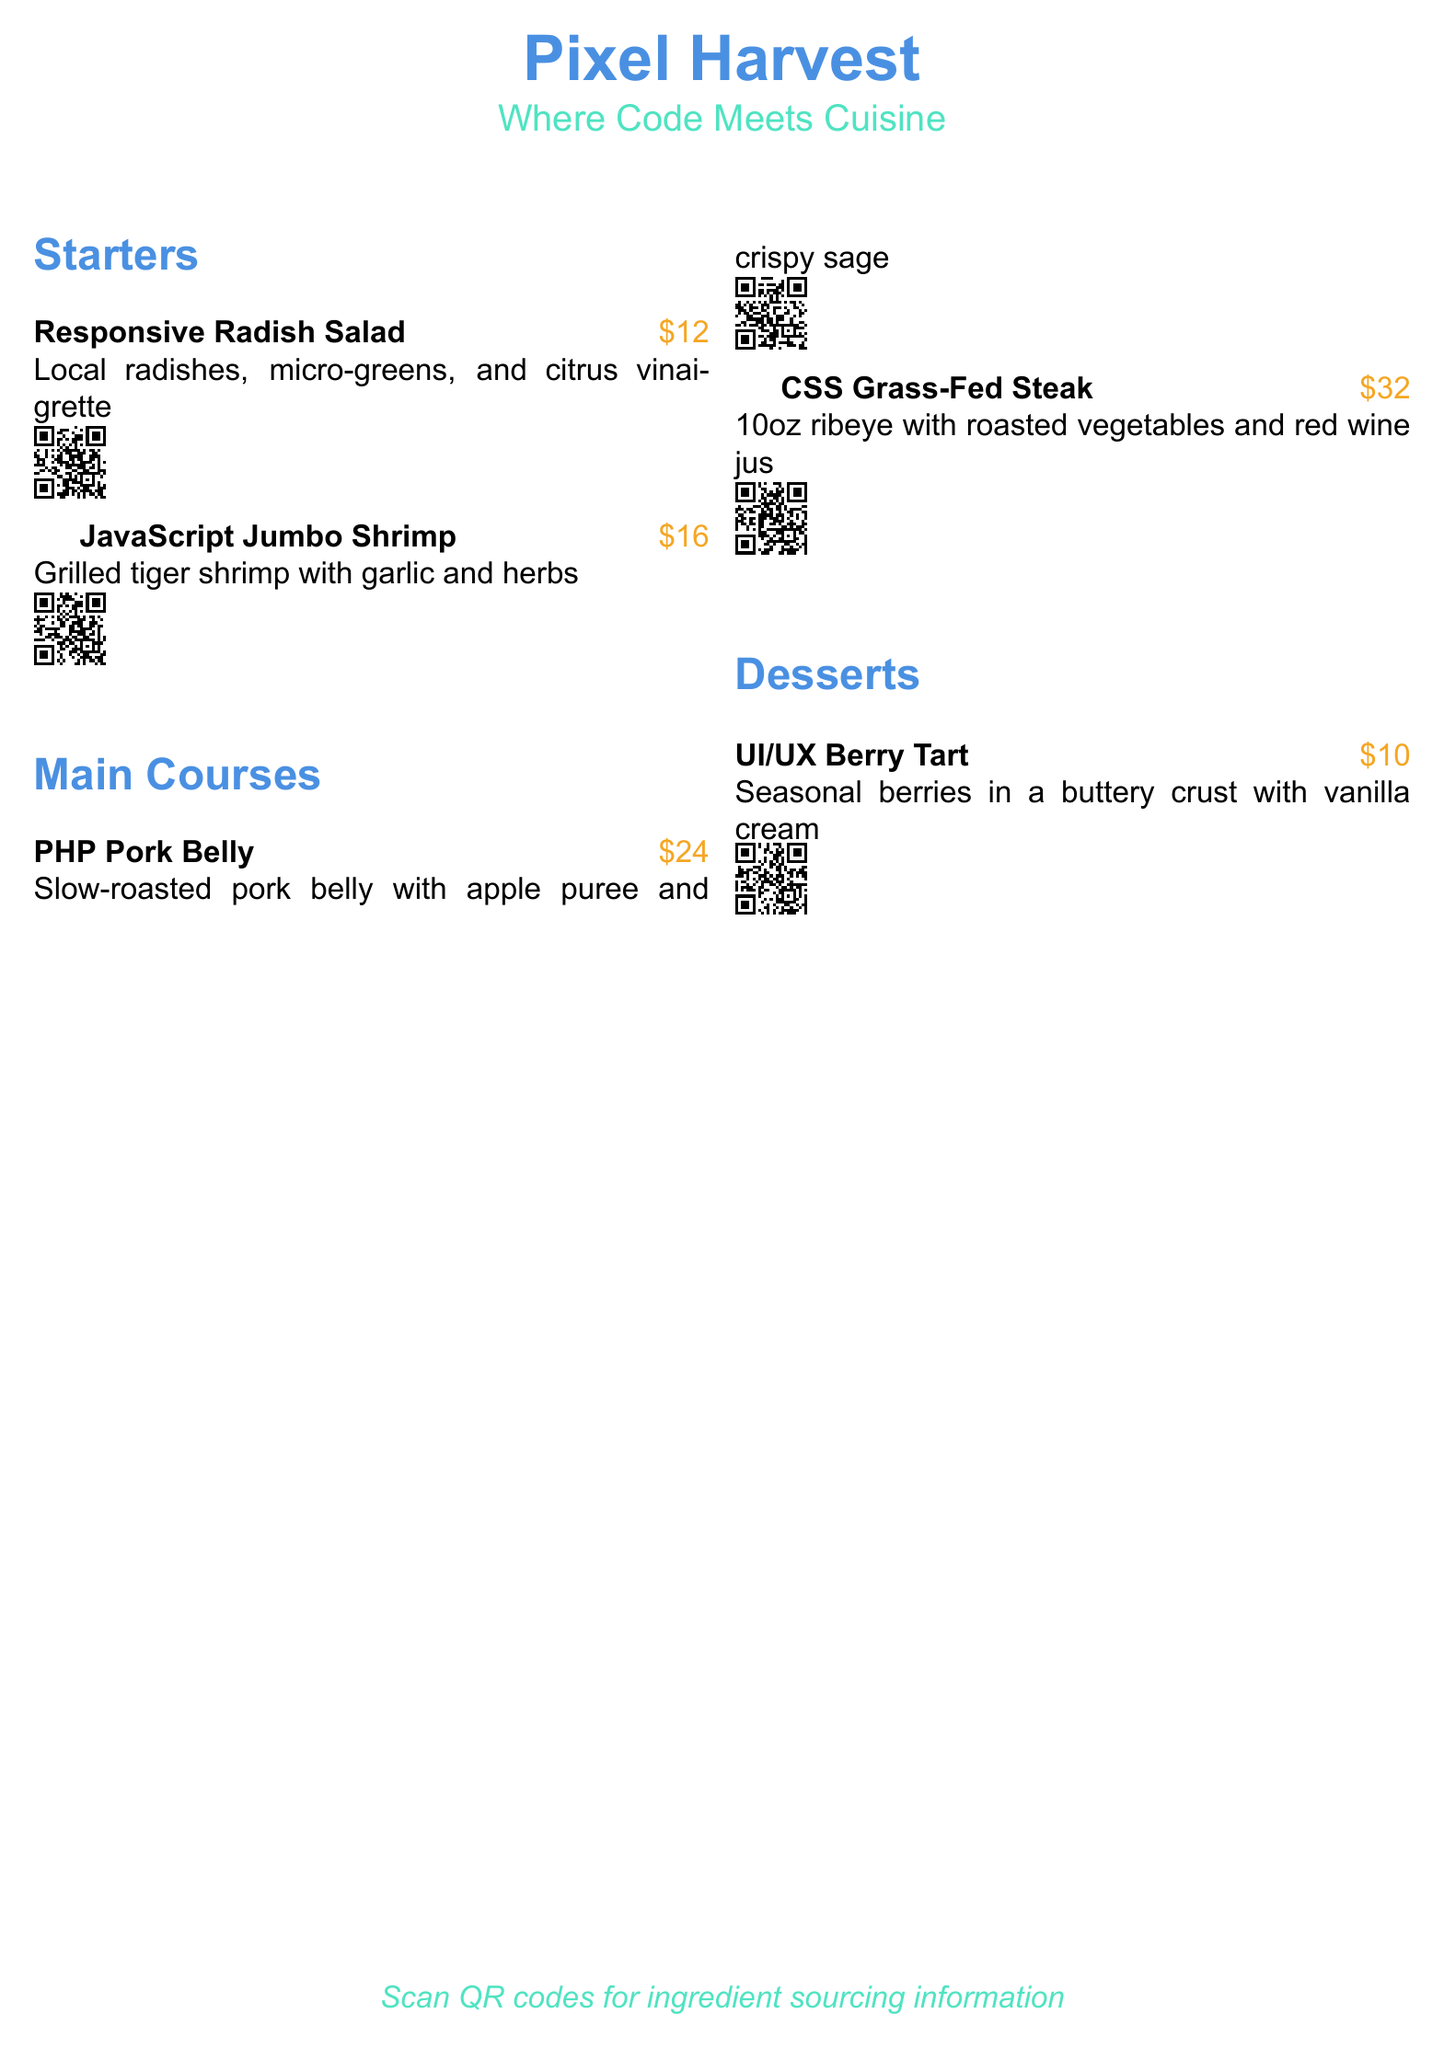What is the name of the restaurant? The name of the restaurant is prominently displayed at the top of the menu.
Answer: Pixel Harvest What is the price of the Responsive Radish Salad? The menu states the price right next to the dish name.
Answer: $12 How many main courses are listed in the menu? The main courses section contains two items.
Answer: 2 What type of steak is served in the main courses? The menu specifies the type of steak in the description of the second main course.
Answer: ribeye Which dessert contains seasonal berries? The dessert section describes a dish that includes seasonal berries.
Answer: UI/UX Berry Tart How much does the CSS Grass-Fed Steak cost? The price is included alongside the dish name for easy reference.
Answer: $32 What is highlighted in the QR codes? The QR codes are meant for providing more information regarding the sourcing of ingredients.
Answer: ingredient sourcing What is the description for the PHP Pork Belly? The menu includes a description next to the dish name.
Answer: Slow-roasted pork belly with apple puree and crispy sage What is the main ingredient in the JavaScript Jumbo Shrimp dish? The description includes key ingredients for the dish.
Answer: grilled tiger shrimp 